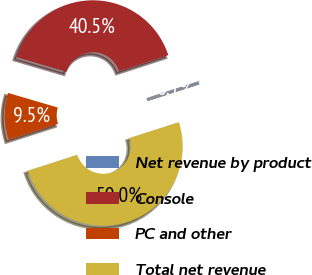Convert chart to OTSL. <chart><loc_0><loc_0><loc_500><loc_500><pie_chart><fcel>Net revenue by product<fcel>Console<fcel>PC and other<fcel>Total net revenue<nl><fcel>0.06%<fcel>40.45%<fcel>9.52%<fcel>49.97%<nl></chart> 